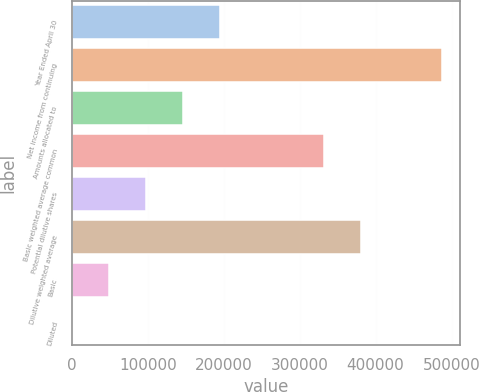Convert chart. <chart><loc_0><loc_0><loc_500><loc_500><bar_chart><fcel>Year Ended April 30<fcel>Net income from continuing<fcel>Amounts allocated to<fcel>Basic weighted average common<fcel>Potential dilutive shares<fcel>Dilutive weighted average<fcel>Basic<fcel>Diluted<nl><fcel>195579<fcel>487058<fcel>146685<fcel>332283<fcel>97790.4<fcel>381177<fcel>48895.9<fcel>1.46<nl></chart> 